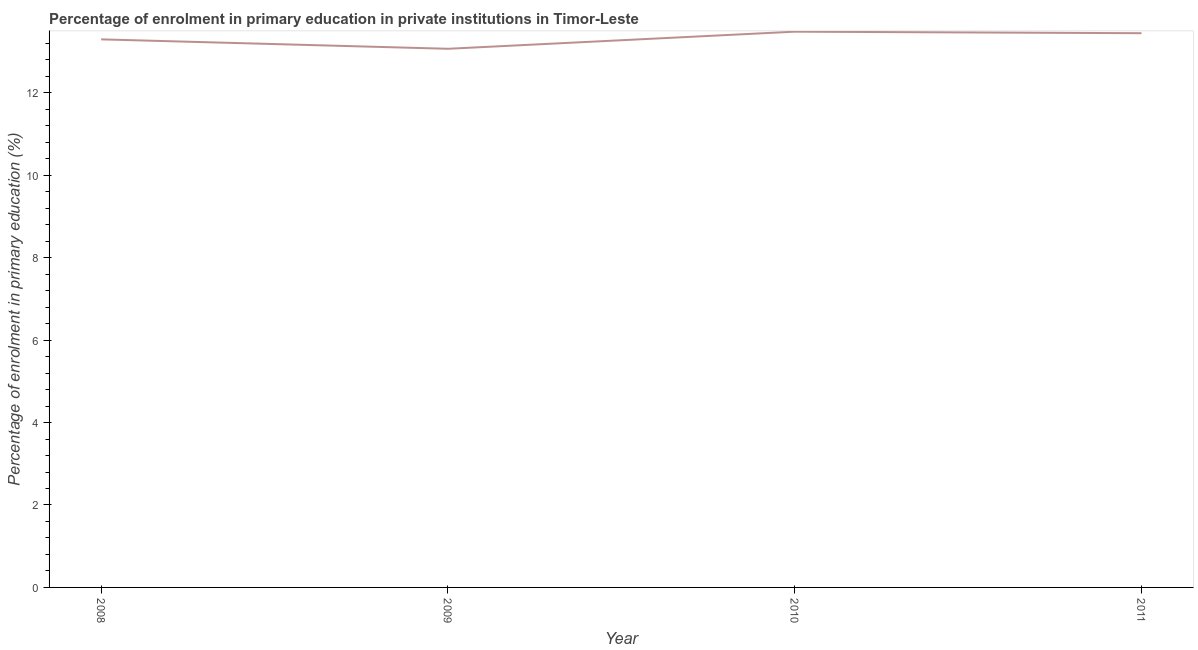What is the enrolment percentage in primary education in 2010?
Ensure brevity in your answer.  13.48. Across all years, what is the maximum enrolment percentage in primary education?
Offer a terse response. 13.48. Across all years, what is the minimum enrolment percentage in primary education?
Offer a terse response. 13.07. In which year was the enrolment percentage in primary education maximum?
Provide a succinct answer. 2010. What is the sum of the enrolment percentage in primary education?
Provide a short and direct response. 53.29. What is the difference between the enrolment percentage in primary education in 2010 and 2011?
Make the answer very short. 0.04. What is the average enrolment percentage in primary education per year?
Offer a very short reply. 13.32. What is the median enrolment percentage in primary education?
Make the answer very short. 13.37. What is the ratio of the enrolment percentage in primary education in 2008 to that in 2009?
Ensure brevity in your answer.  1.02. What is the difference between the highest and the second highest enrolment percentage in primary education?
Your answer should be compact. 0.04. What is the difference between the highest and the lowest enrolment percentage in primary education?
Give a very brief answer. 0.42. Does the enrolment percentage in primary education monotonically increase over the years?
Offer a very short reply. No. How many years are there in the graph?
Give a very brief answer. 4. What is the difference between two consecutive major ticks on the Y-axis?
Offer a very short reply. 2. Are the values on the major ticks of Y-axis written in scientific E-notation?
Your answer should be compact. No. What is the title of the graph?
Provide a succinct answer. Percentage of enrolment in primary education in private institutions in Timor-Leste. What is the label or title of the Y-axis?
Provide a succinct answer. Percentage of enrolment in primary education (%). What is the Percentage of enrolment in primary education (%) of 2008?
Give a very brief answer. 13.3. What is the Percentage of enrolment in primary education (%) in 2009?
Ensure brevity in your answer.  13.07. What is the Percentage of enrolment in primary education (%) of 2010?
Give a very brief answer. 13.48. What is the Percentage of enrolment in primary education (%) in 2011?
Keep it short and to the point. 13.45. What is the difference between the Percentage of enrolment in primary education (%) in 2008 and 2009?
Provide a succinct answer. 0.23. What is the difference between the Percentage of enrolment in primary education (%) in 2008 and 2010?
Offer a terse response. -0.19. What is the difference between the Percentage of enrolment in primary education (%) in 2008 and 2011?
Keep it short and to the point. -0.15. What is the difference between the Percentage of enrolment in primary education (%) in 2009 and 2010?
Keep it short and to the point. -0.42. What is the difference between the Percentage of enrolment in primary education (%) in 2009 and 2011?
Make the answer very short. -0.38. What is the difference between the Percentage of enrolment in primary education (%) in 2010 and 2011?
Your response must be concise. 0.04. What is the ratio of the Percentage of enrolment in primary education (%) in 2010 to that in 2011?
Provide a short and direct response. 1. 